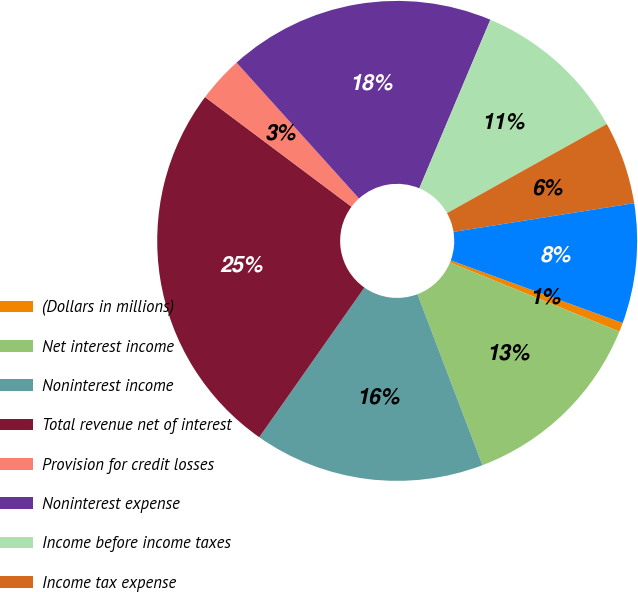Convert chart to OTSL. <chart><loc_0><loc_0><loc_500><loc_500><pie_chart><fcel>(Dollars in millions)<fcel>Net interest income<fcel>Noninterest income<fcel>Total revenue net of interest<fcel>Provision for credit losses<fcel>Noninterest expense<fcel>Income before income taxes<fcel>Income tax expense<fcel>Net income<nl><fcel>0.61%<fcel>13.05%<fcel>15.53%<fcel>25.48%<fcel>3.1%<fcel>18.02%<fcel>10.56%<fcel>5.58%<fcel>8.07%<nl></chart> 